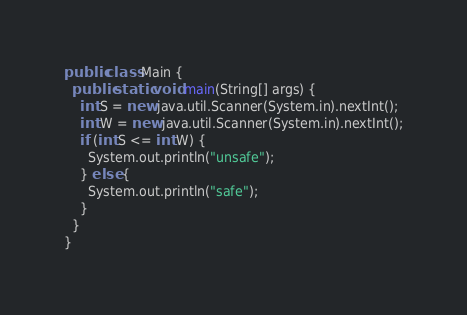Convert code to text. <code><loc_0><loc_0><loc_500><loc_500><_Java_>public class Main {
  public static void main(String[] args) {
    int S = new java.util.Scanner(System.in).nextInt();
    int W = new java.util.Scanner(System.in).nextInt();
    if (int S <= int W) {
      System.out.println("unsafe");
    } else {
      System.out.println("safe");
    }
  }
}
</code> 